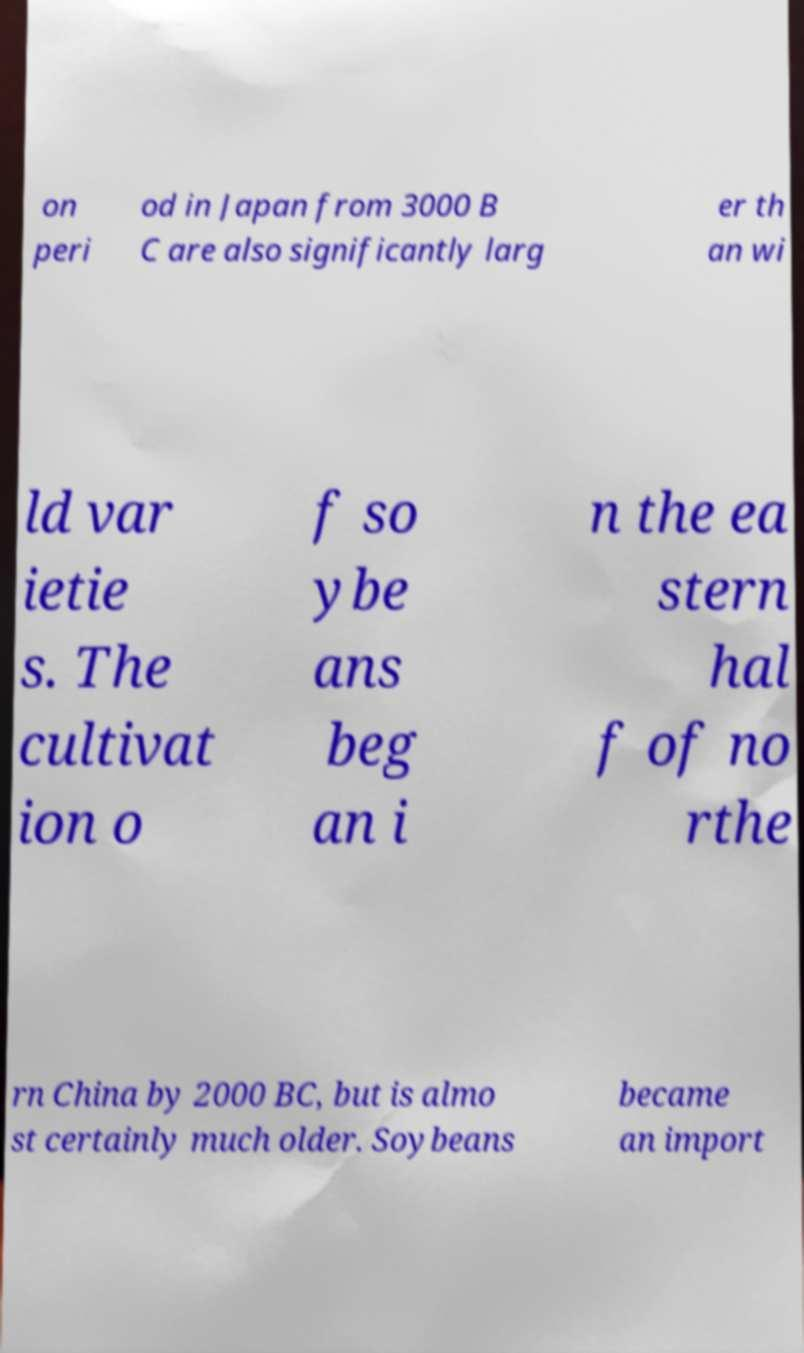What messages or text are displayed in this image? I need them in a readable, typed format. on peri od in Japan from 3000 B C are also significantly larg er th an wi ld var ietie s. The cultivat ion o f so ybe ans beg an i n the ea stern hal f of no rthe rn China by 2000 BC, but is almo st certainly much older. Soybeans became an import 